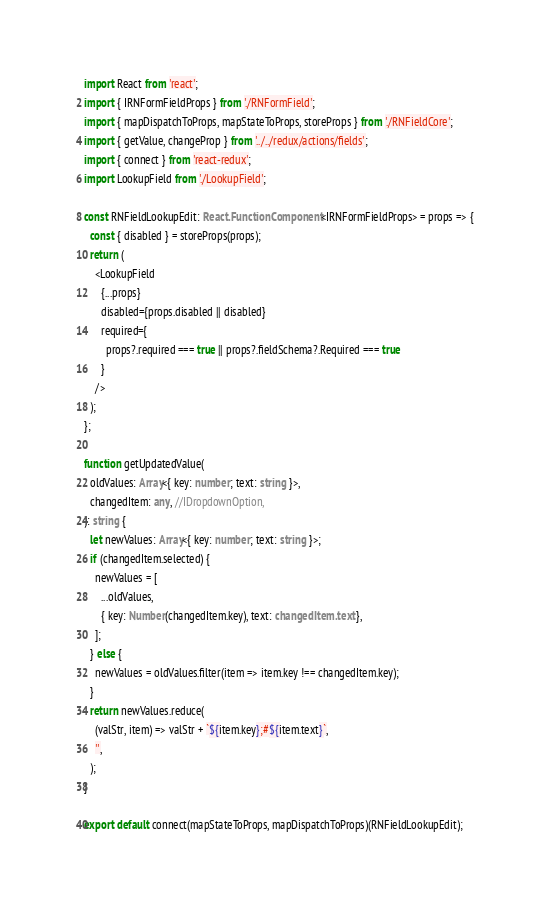<code> <loc_0><loc_0><loc_500><loc_500><_TypeScript_>import React from 'react';
import { IRNFormFieldProps } from './RNFormField';
import { mapDispatchToProps, mapStateToProps, storeProps } from './RNFieldCore';
import { getValue, changeProp } from '../../redux/actions/fields';
import { connect } from 'react-redux';
import LookupField from './LookupField';

const RNFieldLookupEdit: React.FunctionComponent<IRNFormFieldProps> = props => {
  const { disabled } = storeProps(props);
  return (
    <LookupField
      {...props}
      disabled={props.disabled || disabled}
      required={
        props?.required === true || props?.fieldSchema?.Required === true
      }
    />
  );
};

function getUpdatedValue(
  oldValues: Array<{ key: number; text: string }>,
  changedItem: any, //IDropdownOption,
): string {
  let newValues: Array<{ key: number; text: string }>;
  if (changedItem.selected) {
    newValues = [
      ...oldValues,
      { key: Number(changedItem.key), text: changedItem.text },
    ];
  } else {
    newValues = oldValues.filter(item => item.key !== changedItem.key);
  }
  return newValues.reduce(
    (valStr, item) => valStr + `${item.key};#${item.text}`,
    '',
  );
}

export default connect(mapStateToProps, mapDispatchToProps)(RNFieldLookupEdit);
</code> 